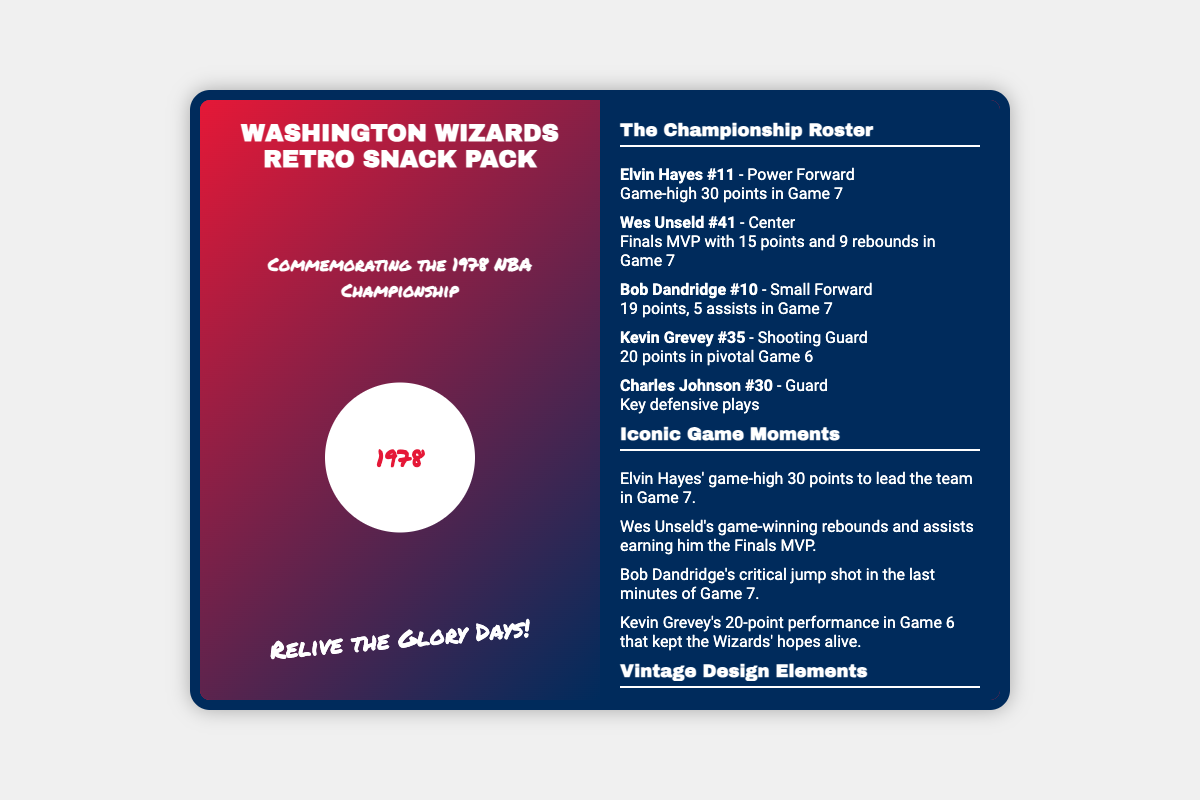What is the main theme of the snack pack? The theme of the snack pack is to commemorate the 1978 NBA Championship.
Answer: 1978 NBA Championship Who is featured as the Finals MVP? The document indicates Wes Unseld as the Finals MVP.
Answer: Wes Unseld How many points did Elvin Hayes score in Game 7? The text states that Elvin Hayes scored a game-high 30 points in Game 7.
Answer: 30 points What are the official team colors mentioned? The document lists the official team colors as Red, White, and Blue.
Answer: Red, White, and Blue What is included in the nutritional information for calories? The nutritional information section provides the calories as 250.
Answer: 250 Which player contributed a key performance in Game 6? Kevin Grevey is mentioned for his pivotal performance in Game 6.
Answer: Kevin Grevey What year does the commemorative logo represent? The logo on the packaging represents the year 1978.
Answer: 1978 How many player profiles are included in the packaging? There are five player profiles included on the back of the packaging.
Answer: Five player profiles What is the tagline on the front of the snack pack? The tagline encourages reliving the team's glory days.
Answer: Relive the Glory Days! 